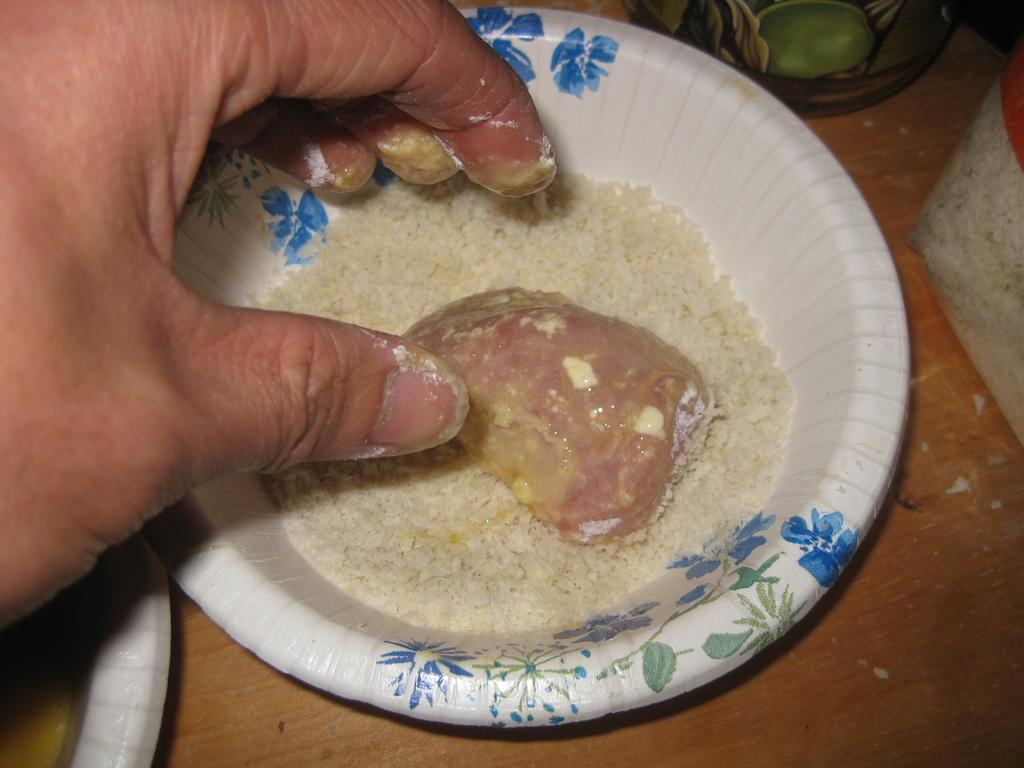What is in the bowl that is visible in the image? There is a food item in a bowl in the image. What is the bowl placed on in the image? The bowl is placed on a wooden surface. Can you describe any human presence in the image? A human hand is visible in the image. What type of humor can be seen in the passenger's facial expression in the image? There is no passenger present in the image, and therefore no facial expression to analyze for humor. 